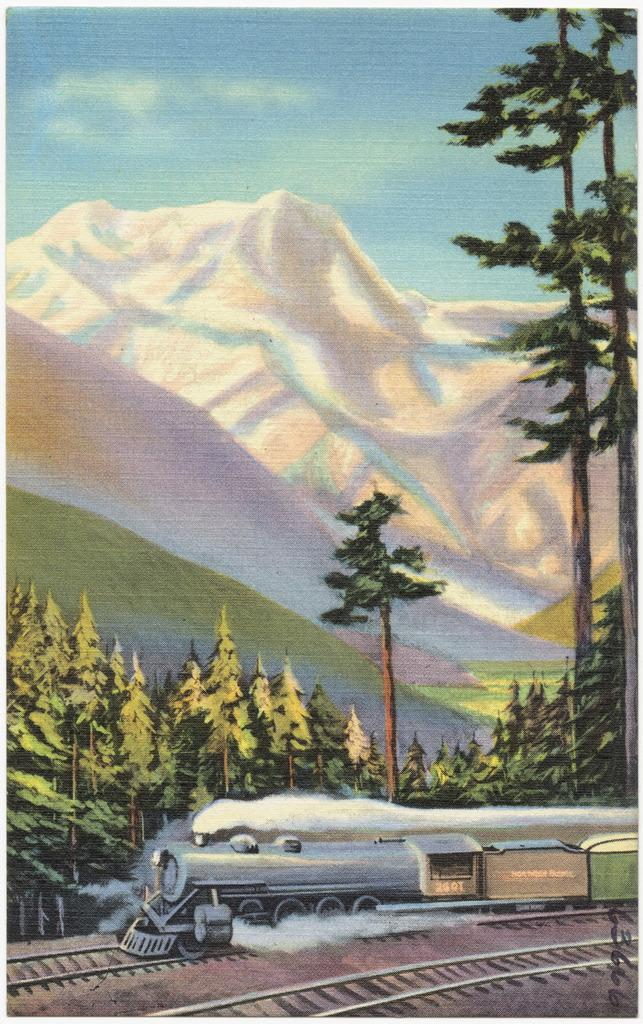What type of transportation infrastructure is visible in the image? There are railway tracks in the image. What is traveling along the railway tracks? There is a train in the image. What type of natural environment is visible in the image? There are trees and mountains in the image. What is visible in the sky in the image? The sky is visible in the image. What type of drink is being served in the train's dining car in the image? There is no information about a dining car or any drinks being served in the image. 